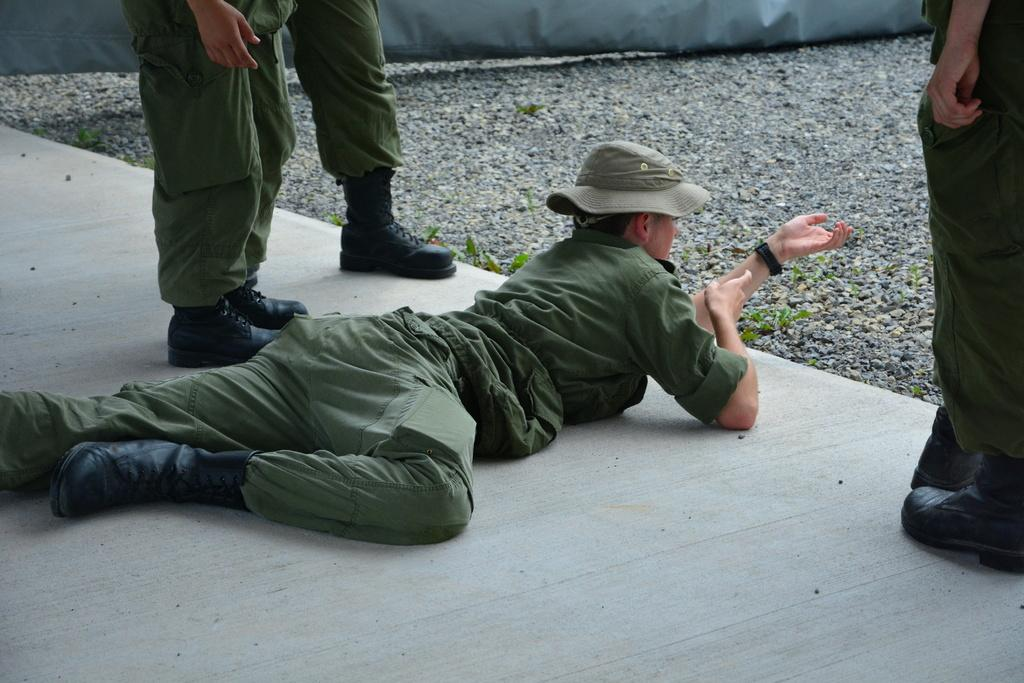What is the position of the person in the image? There is a person lying down on the floor in the image. What is the person wearing on their head? The person is wearing a hat. What type of vegetation can be seen in the image? There are plants visible in the image. What type of material is present in the image? There are stones in the image. What can be used to cover or block a window or doorway? There is a curtain in the image. How many people are standing beside the person lying down? There is a group of people standing beside the person lying down. What type of nut is being used to water the plants in the image? There is no nut present in the image, nor is there any indication of watering the plants. 